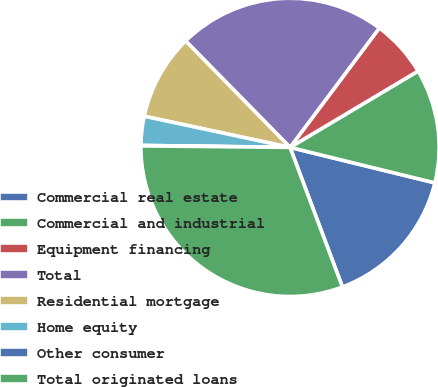Convert chart. <chart><loc_0><loc_0><loc_500><loc_500><pie_chart><fcel>Commercial real estate<fcel>Commercial and industrial<fcel>Equipment financing<fcel>Total<fcel>Residential mortgage<fcel>Home equity<fcel>Other consumer<fcel>Total originated loans<nl><fcel>15.46%<fcel>12.38%<fcel>6.22%<fcel>22.57%<fcel>9.3%<fcel>3.14%<fcel>0.05%<fcel>30.87%<nl></chart> 